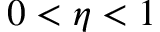Convert formula to latex. <formula><loc_0><loc_0><loc_500><loc_500>0 < \eta < 1</formula> 